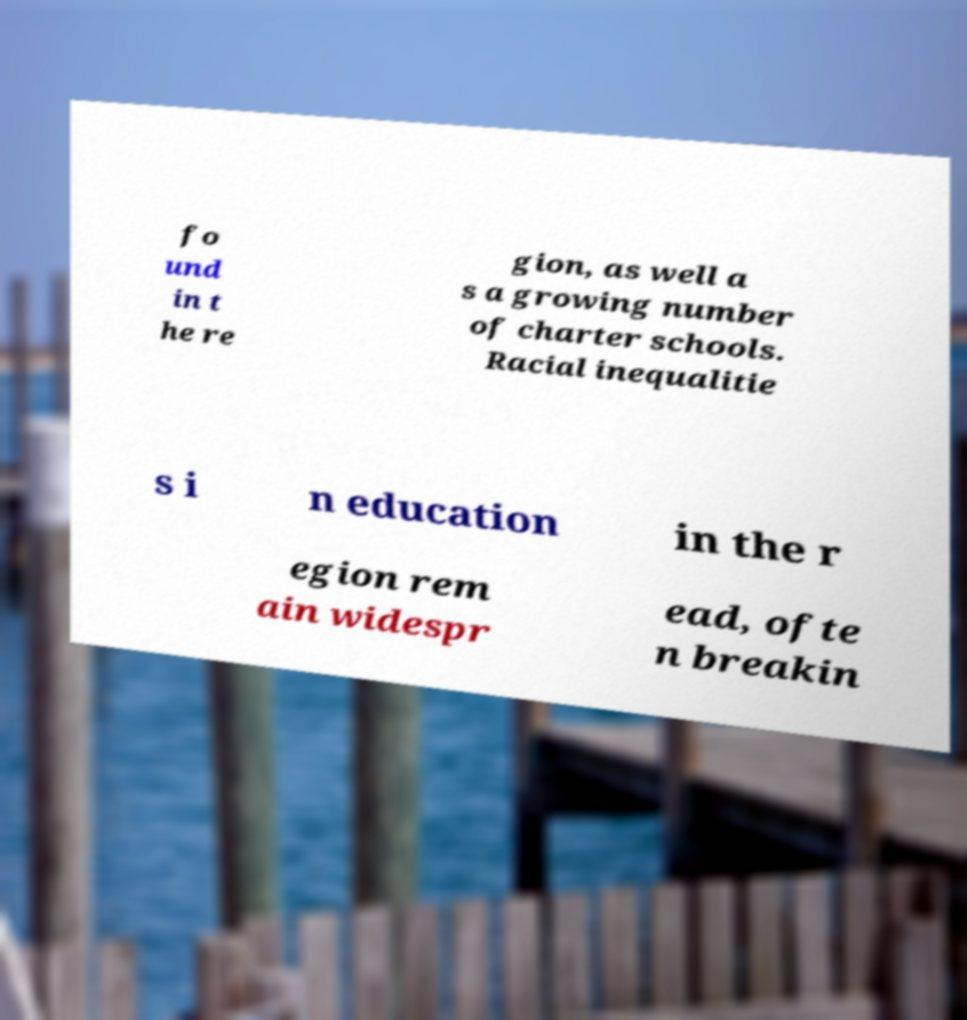What messages or text are displayed in this image? I need them in a readable, typed format. fo und in t he re gion, as well a s a growing number of charter schools. Racial inequalitie s i n education in the r egion rem ain widespr ead, ofte n breakin 